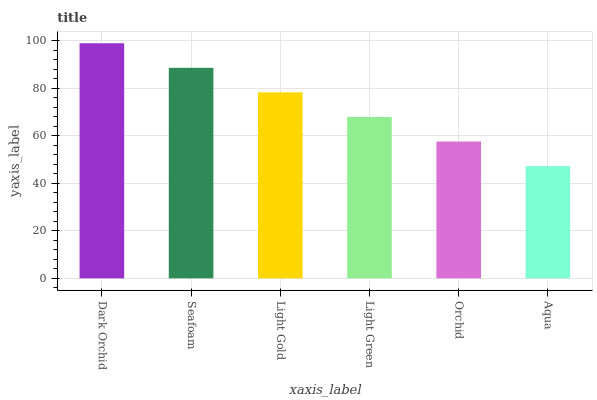Is Seafoam the minimum?
Answer yes or no. No. Is Seafoam the maximum?
Answer yes or no. No. Is Dark Orchid greater than Seafoam?
Answer yes or no. Yes. Is Seafoam less than Dark Orchid?
Answer yes or no. Yes. Is Seafoam greater than Dark Orchid?
Answer yes or no. No. Is Dark Orchid less than Seafoam?
Answer yes or no. No. Is Light Gold the high median?
Answer yes or no. Yes. Is Light Green the low median?
Answer yes or no. Yes. Is Dark Orchid the high median?
Answer yes or no. No. Is Aqua the low median?
Answer yes or no. No. 